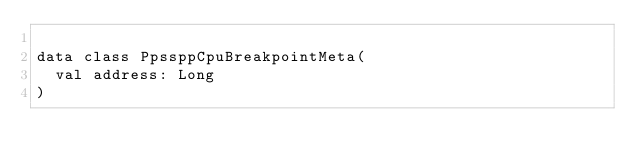Convert code to text. <code><loc_0><loc_0><loc_500><loc_500><_Kotlin_>
data class PpssppCpuBreakpointMeta(
  val address: Long
)
</code> 